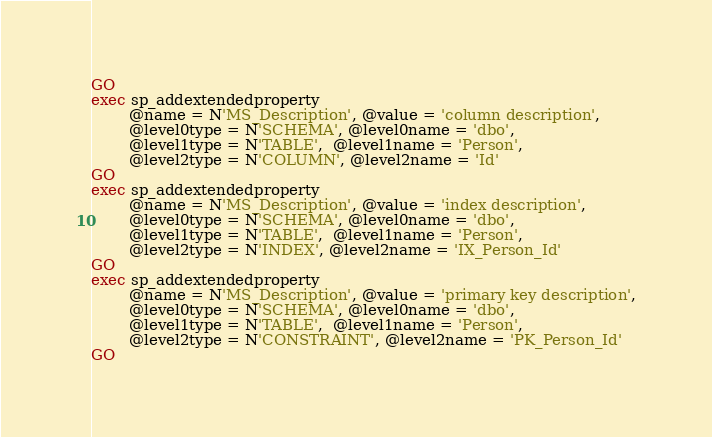Convert code to text. <code><loc_0><loc_0><loc_500><loc_500><_SQL_>GO
exec sp_addextendedproperty 
		@name = N'MS_Description', @value = 'column description',
		@level0type = N'SCHEMA', @level0name = 'dbo', 
		@level1type = N'TABLE',  @level1name = 'Person',
		@level2type = N'COLUMN', @level2name = 'Id'
GO
exec sp_addextendedproperty 
		@name = N'MS_Description', @value = 'index description',
		@level0type = N'SCHEMA', @level0name = 'dbo', 
		@level1type = N'TABLE',  @level1name = 'Person',
		@level2type = N'INDEX', @level2name = 'IX_Person_Id'
GO
exec sp_addextendedproperty 
		@name = N'MS_Description', @value = 'primary key description',
		@level0type = N'SCHEMA', @level0name = 'dbo', 
		@level1type = N'TABLE',  @level1name = 'Person',
		@level2type = N'CONSTRAINT', @level2name = 'PK_Person_Id'
GO</code> 